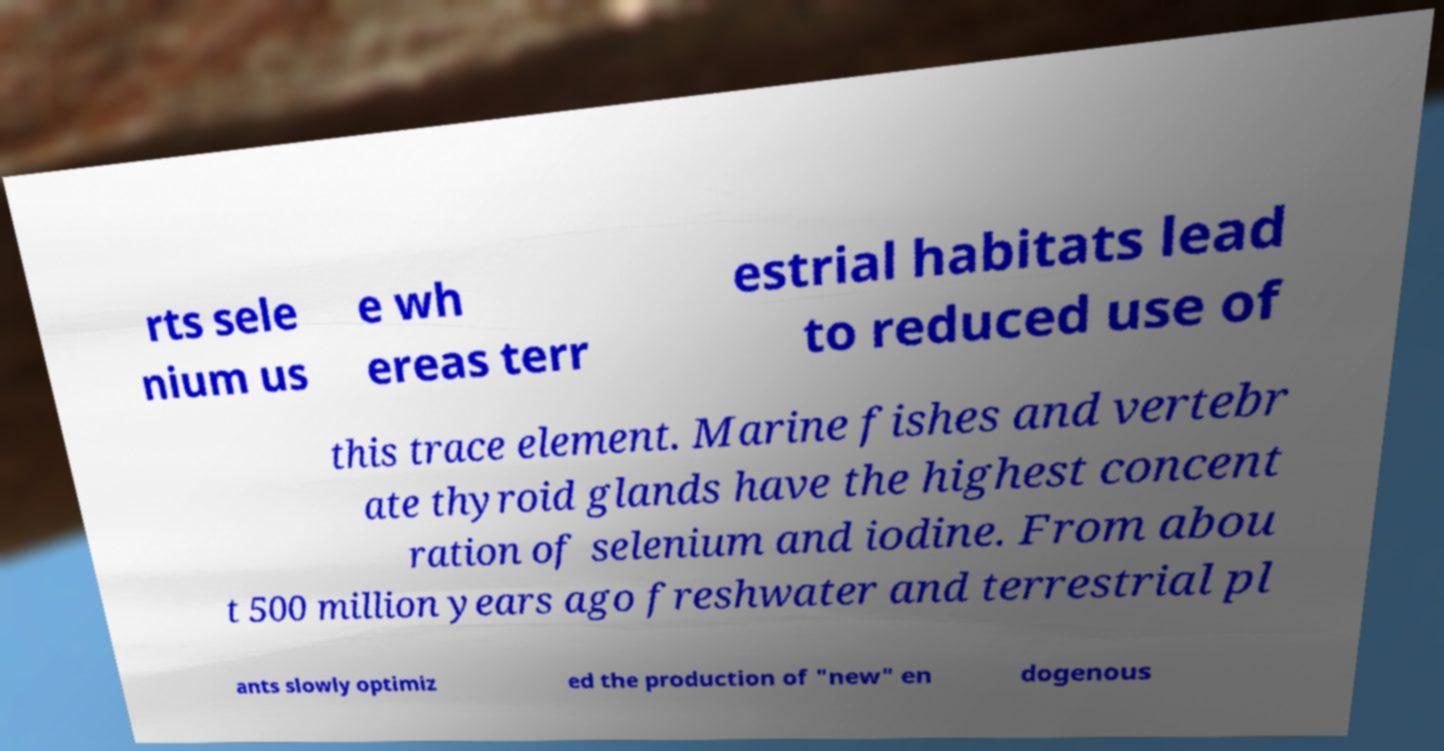There's text embedded in this image that I need extracted. Can you transcribe it verbatim? rts sele nium us e wh ereas terr estrial habitats lead to reduced use of this trace element. Marine fishes and vertebr ate thyroid glands have the highest concent ration of selenium and iodine. From abou t 500 million years ago freshwater and terrestrial pl ants slowly optimiz ed the production of "new" en dogenous 